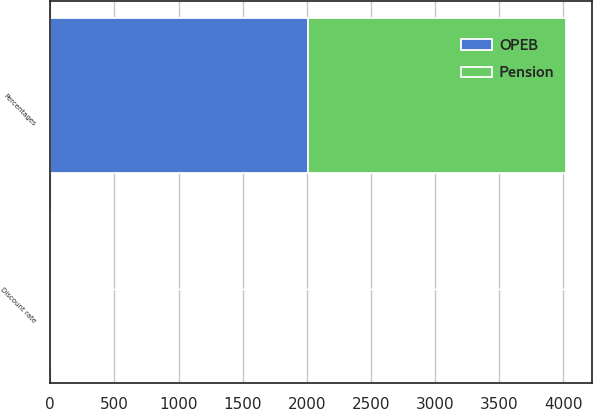Convert chart to OTSL. <chart><loc_0><loc_0><loc_500><loc_500><stacked_bar_chart><ecel><fcel>Percentages<fcel>Discount rate<nl><fcel>Pension<fcel>2013<fcel>3.78<nl><fcel>OPEB<fcel>2013<fcel>3.48<nl></chart> 